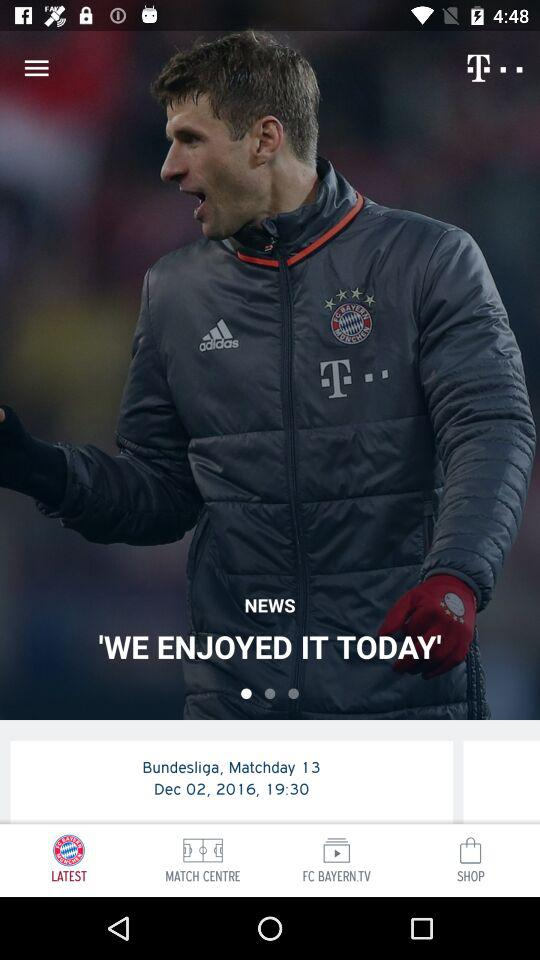What time did the match begin? The match began at 19:30. 